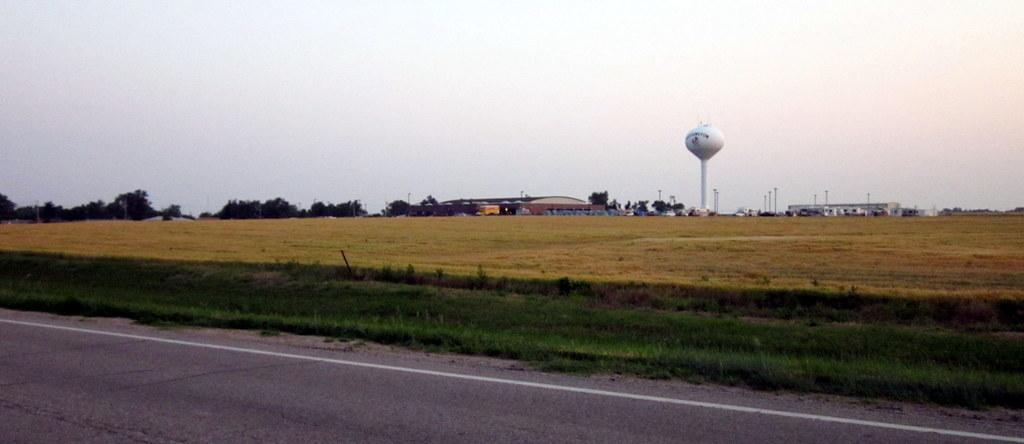What type of vegetation is present on the ground in the center of the image? There is grass on the ground in the center of the image. What can be seen in the background of the image? There are trees, poles, buildings, and a tower in the background of the image. What is the condition of the sky in the image? The sky is cloudy in the image. What type of canvas is being used to paint the landscape in the image? There is no canvas present in the image, as it is a photograph of a real-life scene. What religious beliefs are being practiced by the people in the image? There are no people visible in the image, so it is impossible to determine their religious beliefs. 